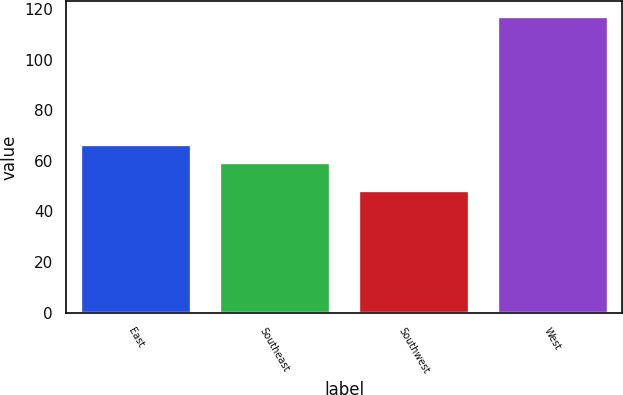<chart> <loc_0><loc_0><loc_500><loc_500><bar_chart><fcel>East<fcel>Southeast<fcel>Southwest<fcel>West<nl><fcel>66.59<fcel>59.7<fcel>48.3<fcel>117.2<nl></chart> 